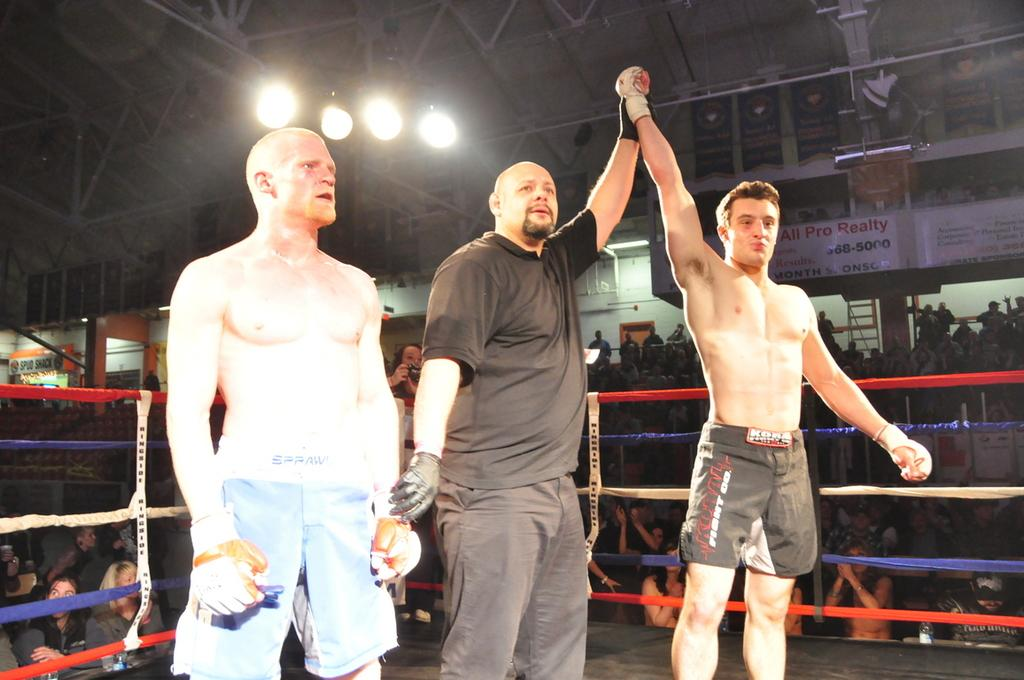Who is the main subject in the image? There is a man standing in the middle of the image. What is the man wearing? The man is wearing a black dress. Is there anyone else in the image? Yes, there is another man standing beside the first man. What can be seen at the top of the image? There are lights at the top of the image. What type of sack is being used by the man in the image? There is no sack present in the image; the man is wearing a black dress. How many times does the man sneeze in the image? There is no indication of the man sneezing in the image; he is simply standing. 